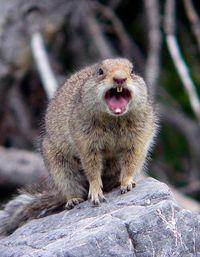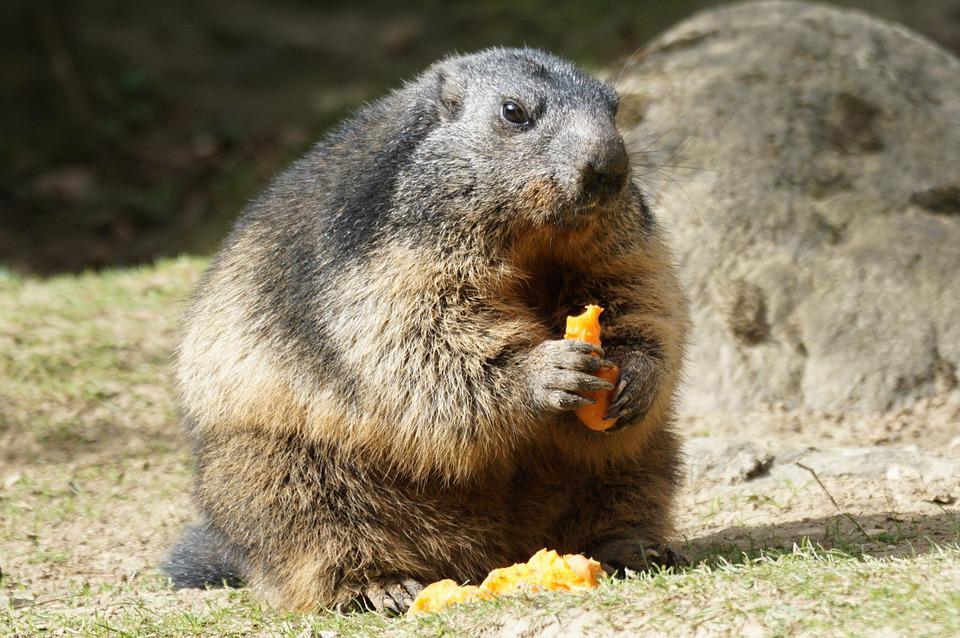The first image is the image on the left, the second image is the image on the right. For the images shown, is this caption "Two animals are eating in the image on the right." true? Answer yes or no. No. The first image is the image on the left, the second image is the image on the right. Considering the images on both sides, is "Right image shows two upright marmots with hands clasping something." valid? Answer yes or no. No. 